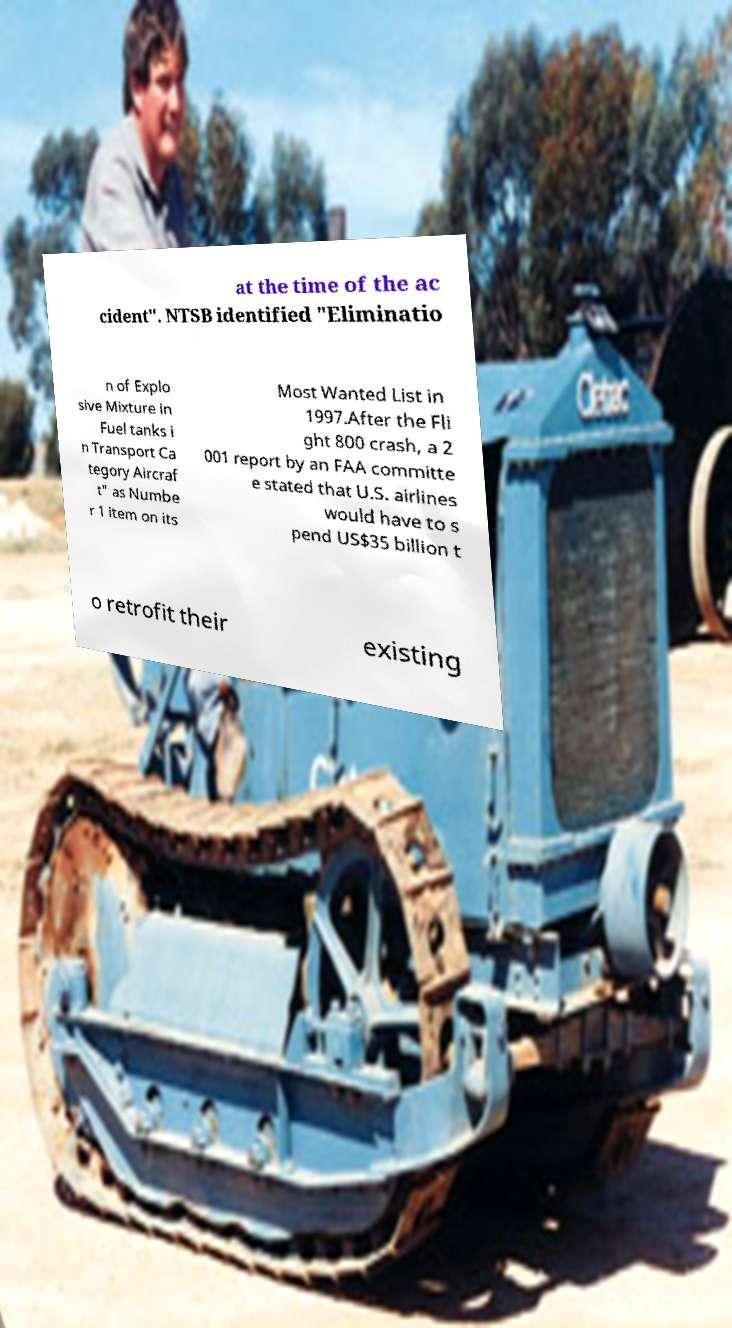What messages or text are displayed in this image? I need them in a readable, typed format. at the time of the ac cident". NTSB identified "Eliminatio n of Explo sive Mixture in Fuel tanks i n Transport Ca tegory Aircraf t" as Numbe r 1 item on its Most Wanted List in 1997.After the Fli ght 800 crash, a 2 001 report by an FAA committe e stated that U.S. airlines would have to s pend US$35 billion t o retrofit their existing 